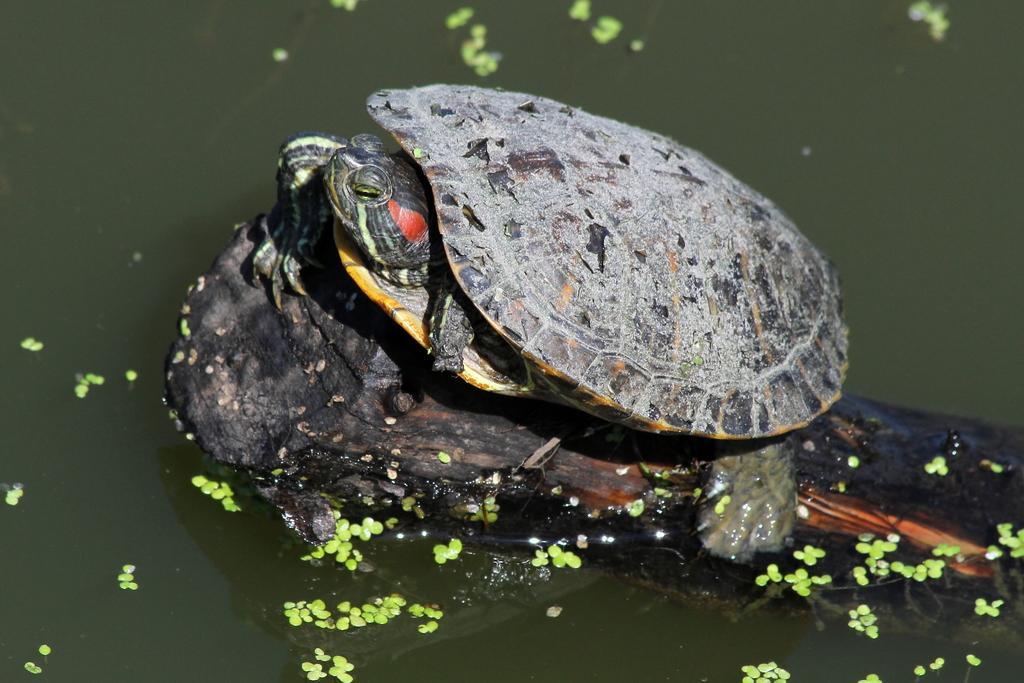How would you summarize this image in a sentence or two? In this picture we can see a turtle on the tree trunk and the tree trunk submerged in the water. On the water there are some leaves. 